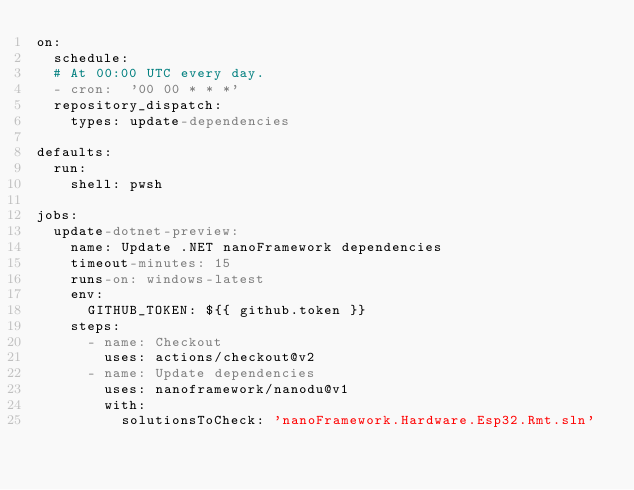<code> <loc_0><loc_0><loc_500><loc_500><_YAML_>on:
  schedule:
  # At 00:00 UTC every day.
  - cron:  '00 00 * * *'
  repository_dispatch:
    types: update-dependencies

defaults:
  run:
    shell: pwsh

jobs:
  update-dotnet-preview:
    name: Update .NET nanoFramework dependencies
    timeout-minutes: 15
    runs-on: windows-latest
    env:
      GITHUB_TOKEN: ${{ github.token }}
    steps:
      - name: Checkout
        uses: actions/checkout@v2
      - name: Update dependencies
        uses: nanoframework/nanodu@v1
        with:
          solutionsToCheck: 'nanoFramework.Hardware.Esp32.Rmt.sln'
</code> 